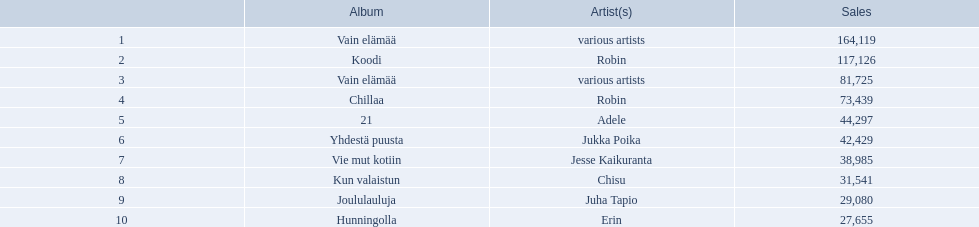Which albums had number-one albums in finland in 2012? 1, Vain elämää, Koodi, Vain elämää, Chillaa, 21, Yhdestä puusta, Vie mut kotiin, Kun valaistun, Joululauluja, Hunningolla. Of those albums, which were recorded by only one artist? Koodi, Chillaa, 21, Yhdestä puusta, Vie mut kotiin, Kun valaistun, Joululauluja, Hunningolla. Which albums made between 30,000 and 45,000 in sales? 21, Yhdestä puusta, Vie mut kotiin, Kun valaistun. Of those albums which had the highest sales? 21. Who was the artist for that album? Adele. 